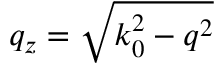Convert formula to latex. <formula><loc_0><loc_0><loc_500><loc_500>q _ { z } = \sqrt { k _ { 0 } ^ { 2 } - q ^ { 2 } }</formula> 